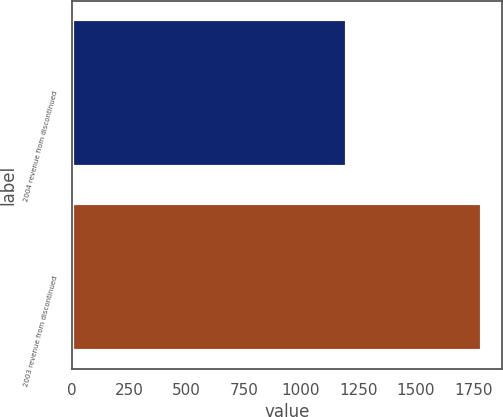<chart> <loc_0><loc_0><loc_500><loc_500><bar_chart><fcel>2004 revenue from discontinued<fcel>2003 revenue from discontinued<nl><fcel>1201<fcel>1788<nl></chart> 